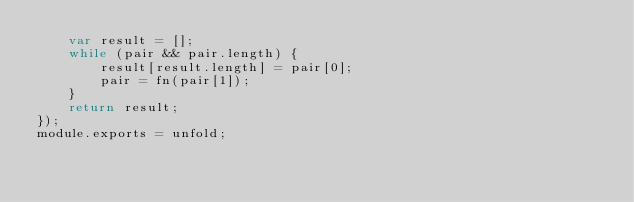<code> <loc_0><loc_0><loc_500><loc_500><_JavaScript_>    var result = [];
    while (pair && pair.length) {
        result[result.length] = pair[0];
        pair = fn(pair[1]);
    }
    return result;
});
module.exports = unfold;
</code> 